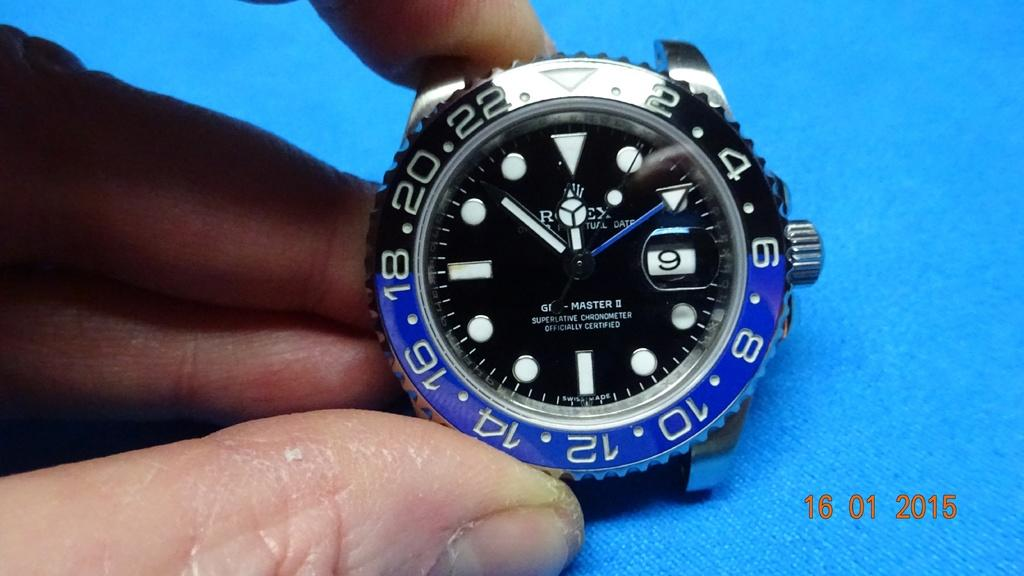<image>
Share a concise interpretation of the image provided. A Rolex watch is shown with a time stamp of the year 2015 to the right of it. 